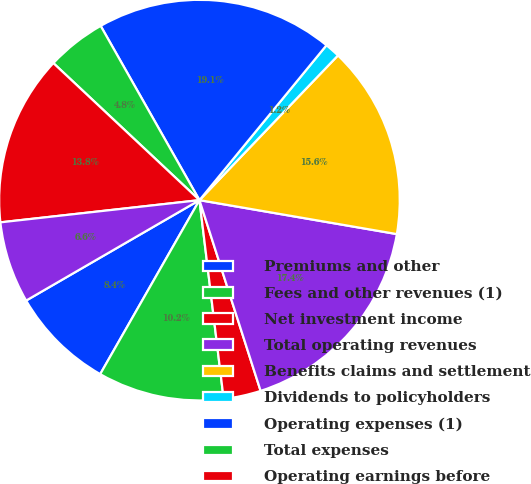Convert chart. <chart><loc_0><loc_0><loc_500><loc_500><pie_chart><fcel>Premiums and other<fcel>Fees and other revenues (1)<fcel>Net investment income<fcel>Total operating revenues<fcel>Benefits claims and settlement<fcel>Dividends to policyholders<fcel>Operating expenses (1)<fcel>Total expenses<fcel>Operating earnings before<fcel>Income taxes<nl><fcel>8.39%<fcel>10.18%<fcel>3.01%<fcel>17.35%<fcel>15.56%<fcel>1.22%<fcel>19.14%<fcel>4.8%<fcel>13.76%<fcel>6.59%<nl></chart> 